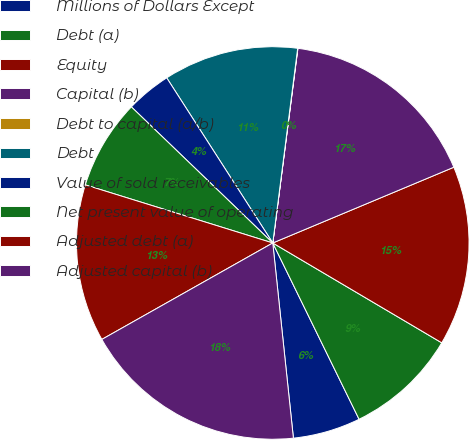Convert chart. <chart><loc_0><loc_0><loc_500><loc_500><pie_chart><fcel>Millions of Dollars Except<fcel>Debt (a)<fcel>Equity<fcel>Capital (b)<fcel>Debt to capital (a/b)<fcel>Debt<fcel>Value of sold receivables<fcel>Net present value of operating<fcel>Adjusted debt (a)<fcel>Adjusted capital (b)<nl><fcel>5.57%<fcel>9.26%<fcel>14.8%<fcel>16.65%<fcel>0.02%<fcel>11.11%<fcel>3.72%<fcel>7.41%<fcel>12.96%<fcel>18.5%<nl></chart> 